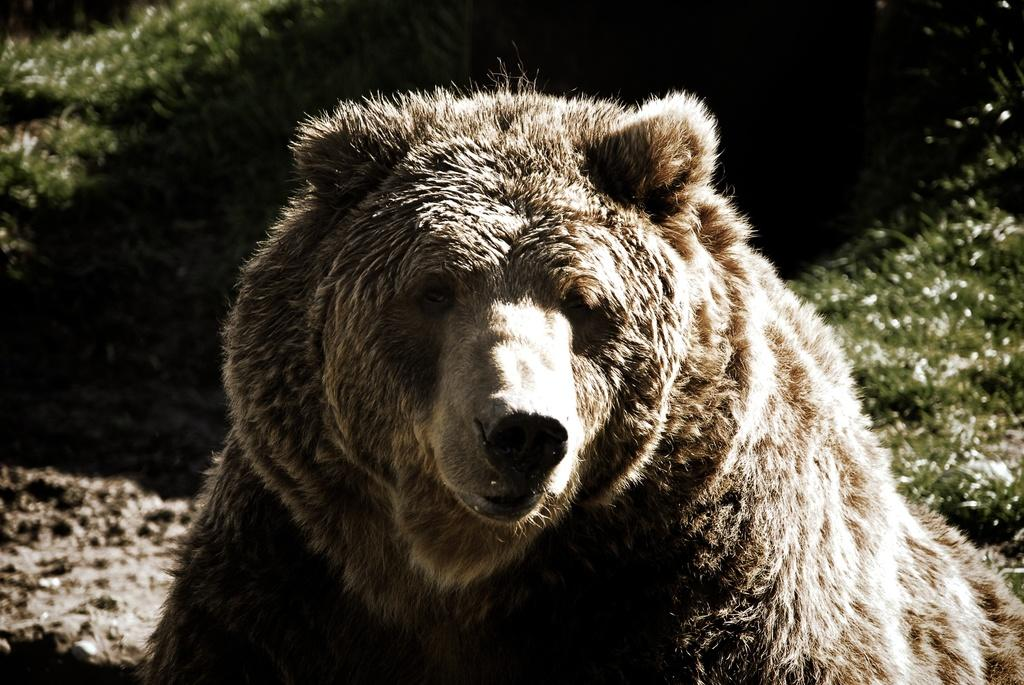What animal is in the image? There is a bear in the image. Where is the bear located? The bear is present on the ground. What type of surface is the bear standing on? The ground is covered with grass. Who is the manager of the office building in the image? There is no office building or manager present in the image; it features a bear on grass. 